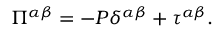Convert formula to latex. <formula><loc_0><loc_0><loc_500><loc_500>\Pi ^ { \alpha \beta } = - P \delta ^ { \alpha \beta } + \tau ^ { \alpha \beta } .</formula> 